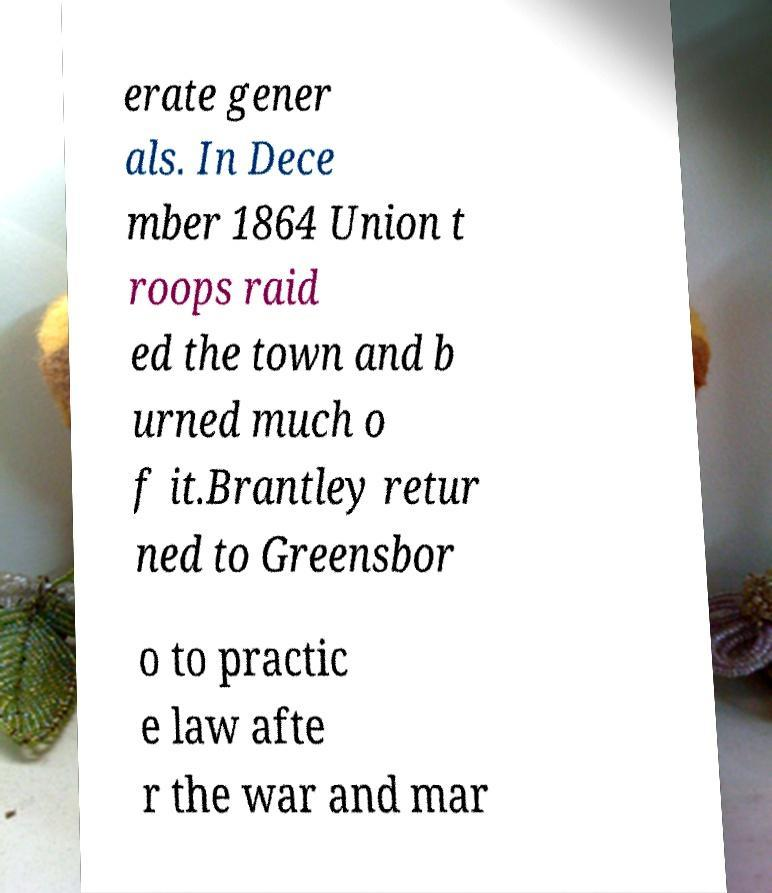For documentation purposes, I need the text within this image transcribed. Could you provide that? erate gener als. In Dece mber 1864 Union t roops raid ed the town and b urned much o f it.Brantley retur ned to Greensbor o to practic e law afte r the war and mar 